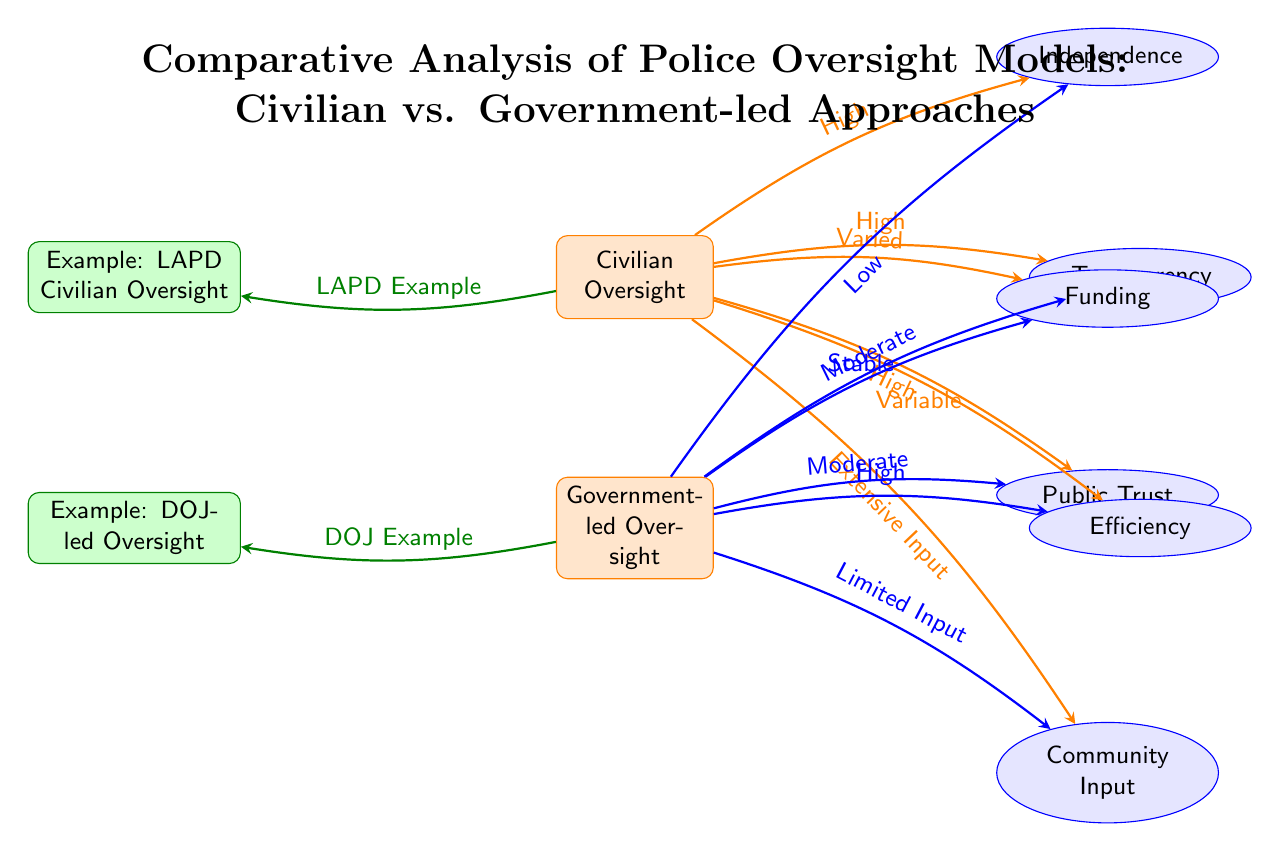What is the level of independence for civilian oversight? The diagram indicates a "High" level of independence for civilian oversight, which is shown by the directed edge from the "Civilian Oversight" node to the "Independence" attribute node.
Answer: High What is the level of transparency for government-led oversight? The diagram shows a "Moderate" level of transparency associated with government-led oversight, as indicated by the directed edge from the "Government-led Oversight" node to the "Transparency" attribute node.
Answer: Moderate Which example is provided for civilian oversight? The diagram lists "LAPD Civilian Oversight" as the example for civilian oversight, shown by the edge connecting "Civilian Oversight" to the example node.
Answer: LAPD Civilian Oversight How does community input differ between civilian and government-led oversight? According to the diagram, "Civilian Oversight" has "Extensive Input" for community involvement whereas "Government-led Oversight" has "Limited Input," which can be seen from the respective edges connecting these nodes to the "Community Input" attribute node.
Answer: Extensive Input vs. Limited Input What is the funding stability for government-led oversight? The diagram notes that funding for government-led oversight is described as "Stable," evidenced by the directed edge from the "Government-led Oversight" node to the "Funding" attribute node that specifies this status.
Answer: Stable 